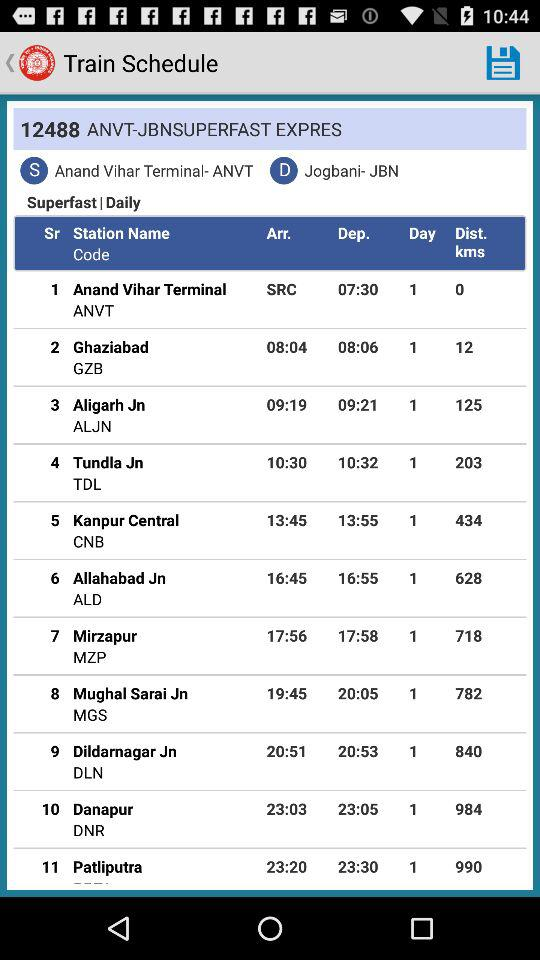On which days does train number 12488 run? The train number 12488 runs on a daily basis. 